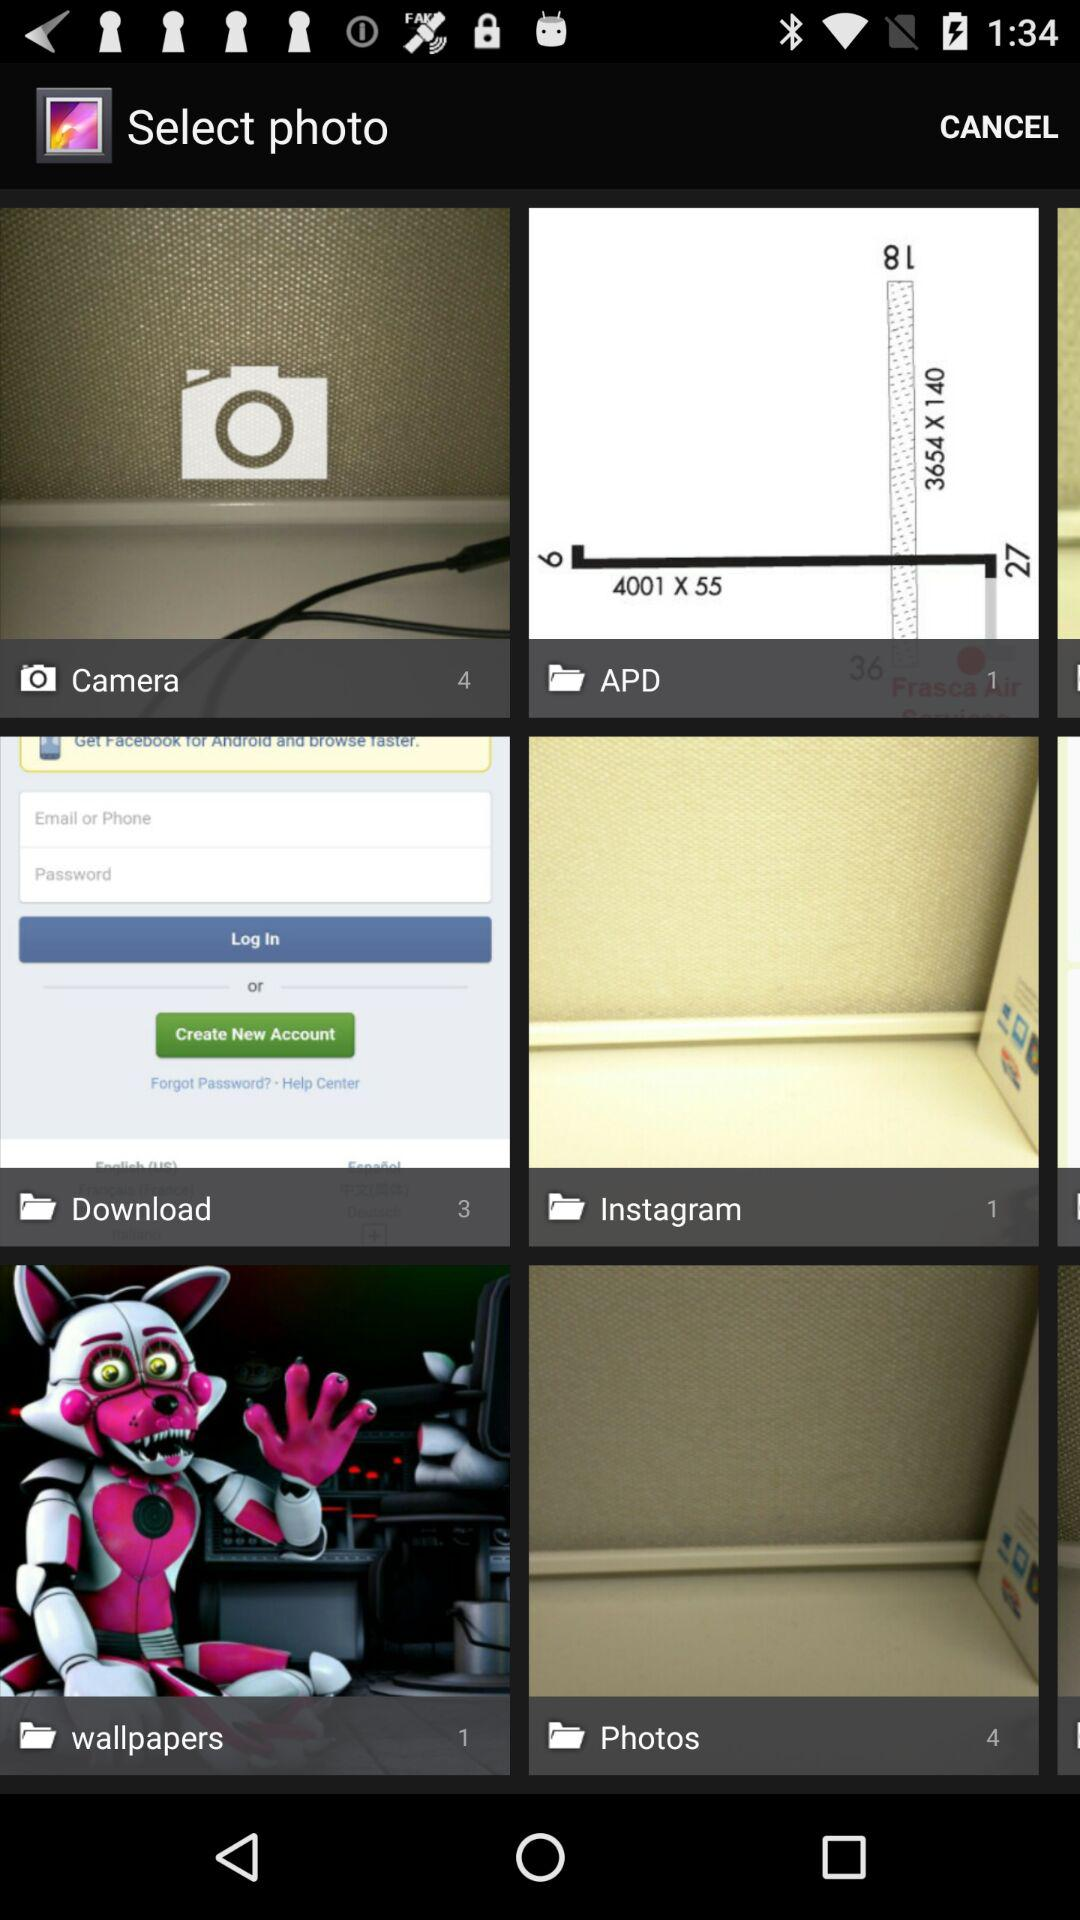What is the number of photos in "Instagram"? The number of photos in "Instagram" is 1. 